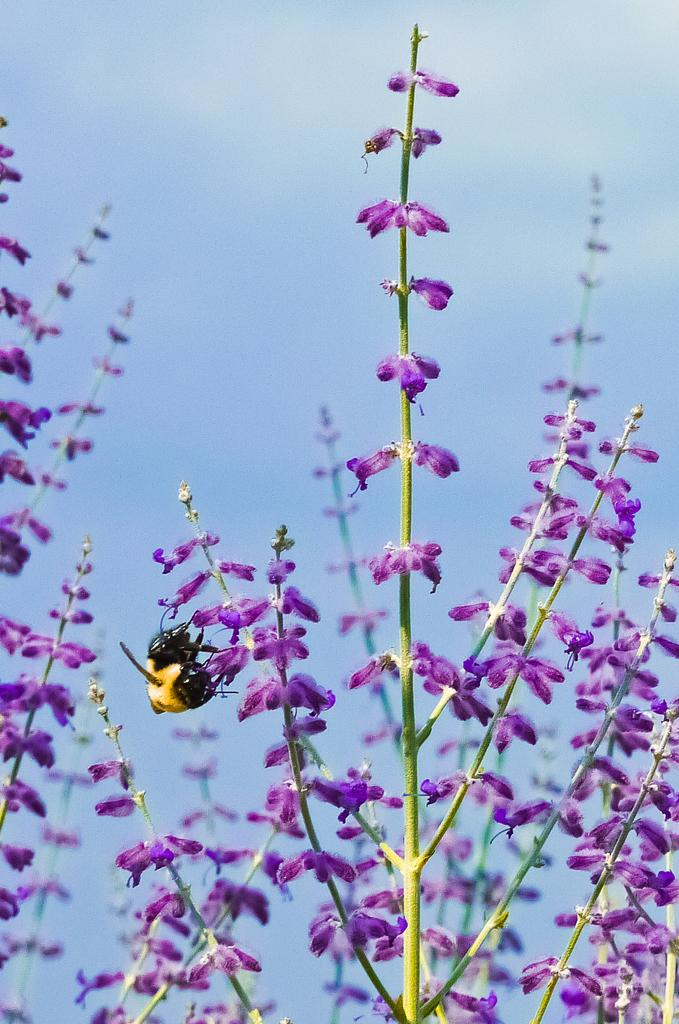What type of insect is present in the image? There is a bee in the image. What is the bee interacting with in the image? The bee is interacting with flowers in the image. What is your sister doing with the porter in the image? There is no sister or porter present in the image; it only features a bee and flowers. 